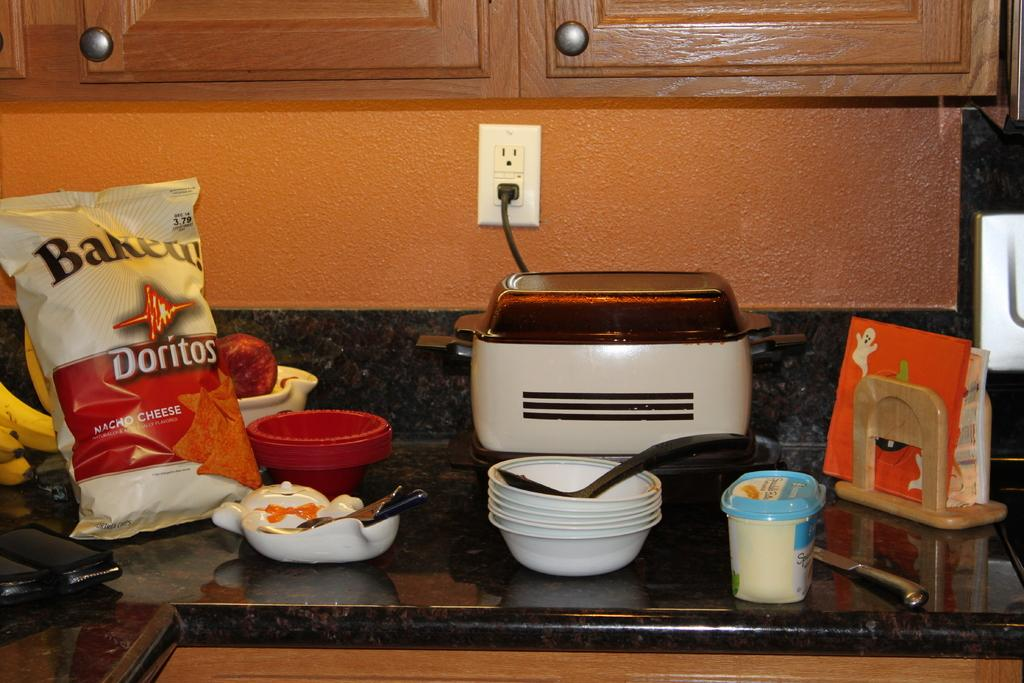<image>
Give a short and clear explanation of the subsequent image. A bag of baked doritoes on the counter next to a crockpot and some dishes. 